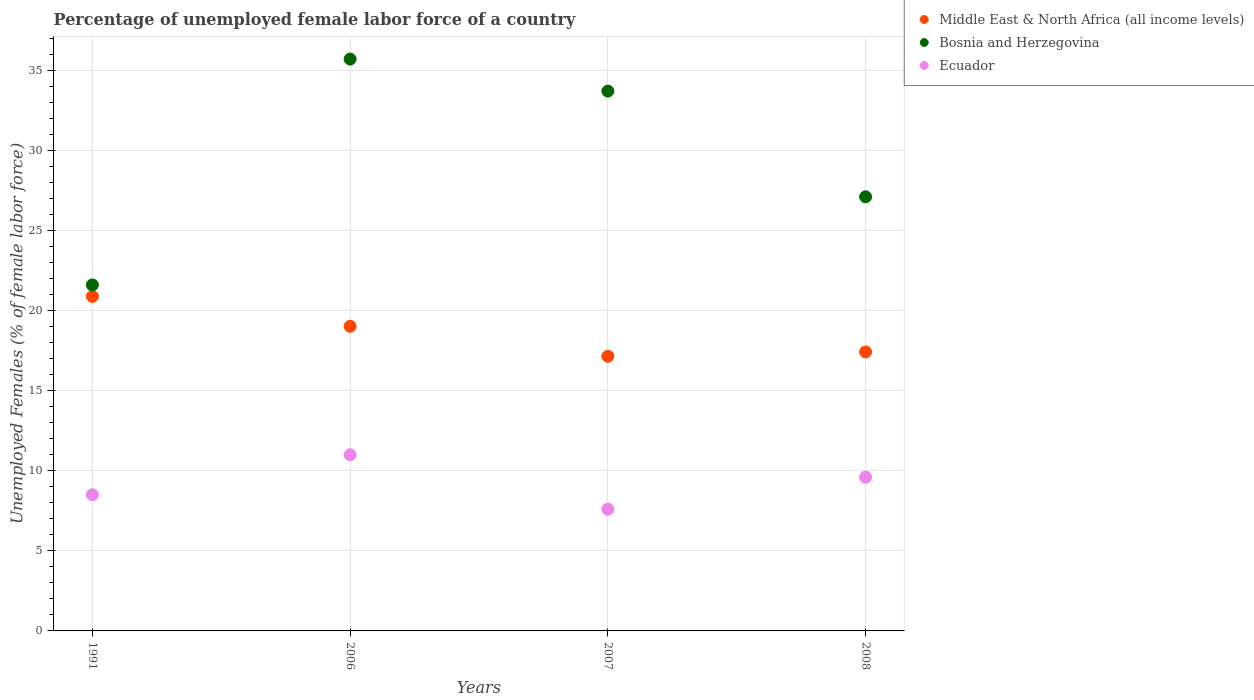What is the percentage of unemployed female labor force in Middle East & North Africa (all income levels) in 1991?
Make the answer very short. 20.88. Across all years, what is the minimum percentage of unemployed female labor force in Ecuador?
Give a very brief answer. 7.6. In which year was the percentage of unemployed female labor force in Ecuador maximum?
Provide a short and direct response. 2006. In which year was the percentage of unemployed female labor force in Middle East & North Africa (all income levels) minimum?
Offer a terse response. 2007. What is the total percentage of unemployed female labor force in Middle East & North Africa (all income levels) in the graph?
Give a very brief answer. 74.47. What is the difference between the percentage of unemployed female labor force in Bosnia and Herzegovina in 2006 and that in 2008?
Provide a short and direct response. 8.6. What is the difference between the percentage of unemployed female labor force in Bosnia and Herzegovina in 2006 and the percentage of unemployed female labor force in Middle East & North Africa (all income levels) in 1991?
Your answer should be very brief. 14.82. What is the average percentage of unemployed female labor force in Bosnia and Herzegovina per year?
Ensure brevity in your answer.  29.53. In the year 2007, what is the difference between the percentage of unemployed female labor force in Bosnia and Herzegovina and percentage of unemployed female labor force in Ecuador?
Offer a very short reply. 26.1. What is the ratio of the percentage of unemployed female labor force in Bosnia and Herzegovina in 1991 to that in 2007?
Make the answer very short. 0.64. What is the difference between the highest and the lowest percentage of unemployed female labor force in Middle East & North Africa (all income levels)?
Offer a terse response. 3.74. In how many years, is the percentage of unemployed female labor force in Middle East & North Africa (all income levels) greater than the average percentage of unemployed female labor force in Middle East & North Africa (all income levels) taken over all years?
Keep it short and to the point. 2. What is the difference between two consecutive major ticks on the Y-axis?
Your answer should be very brief. 5. Where does the legend appear in the graph?
Your response must be concise. Top right. What is the title of the graph?
Make the answer very short. Percentage of unemployed female labor force of a country. Does "United States" appear as one of the legend labels in the graph?
Give a very brief answer. No. What is the label or title of the X-axis?
Provide a succinct answer. Years. What is the label or title of the Y-axis?
Keep it short and to the point. Unemployed Females (% of female labor force). What is the Unemployed Females (% of female labor force) in Middle East & North Africa (all income levels) in 1991?
Offer a very short reply. 20.88. What is the Unemployed Females (% of female labor force) of Bosnia and Herzegovina in 1991?
Provide a succinct answer. 21.6. What is the Unemployed Females (% of female labor force) in Ecuador in 1991?
Ensure brevity in your answer.  8.5. What is the Unemployed Females (% of female labor force) in Middle East & North Africa (all income levels) in 2006?
Your answer should be very brief. 19.02. What is the Unemployed Females (% of female labor force) in Bosnia and Herzegovina in 2006?
Offer a terse response. 35.7. What is the Unemployed Females (% of female labor force) of Ecuador in 2006?
Offer a terse response. 11. What is the Unemployed Females (% of female labor force) in Middle East & North Africa (all income levels) in 2007?
Give a very brief answer. 17.15. What is the Unemployed Females (% of female labor force) in Bosnia and Herzegovina in 2007?
Ensure brevity in your answer.  33.7. What is the Unemployed Females (% of female labor force) of Ecuador in 2007?
Provide a succinct answer. 7.6. What is the Unemployed Females (% of female labor force) in Middle East & North Africa (all income levels) in 2008?
Offer a terse response. 17.41. What is the Unemployed Females (% of female labor force) in Bosnia and Herzegovina in 2008?
Provide a short and direct response. 27.1. What is the Unemployed Females (% of female labor force) in Ecuador in 2008?
Offer a terse response. 9.6. Across all years, what is the maximum Unemployed Females (% of female labor force) of Middle East & North Africa (all income levels)?
Give a very brief answer. 20.88. Across all years, what is the maximum Unemployed Females (% of female labor force) of Bosnia and Herzegovina?
Offer a terse response. 35.7. Across all years, what is the minimum Unemployed Females (% of female labor force) in Middle East & North Africa (all income levels)?
Your response must be concise. 17.15. Across all years, what is the minimum Unemployed Females (% of female labor force) of Bosnia and Herzegovina?
Your answer should be very brief. 21.6. Across all years, what is the minimum Unemployed Females (% of female labor force) in Ecuador?
Keep it short and to the point. 7.6. What is the total Unemployed Females (% of female labor force) of Middle East & North Africa (all income levels) in the graph?
Offer a terse response. 74.47. What is the total Unemployed Females (% of female labor force) of Bosnia and Herzegovina in the graph?
Provide a succinct answer. 118.1. What is the total Unemployed Females (% of female labor force) of Ecuador in the graph?
Offer a terse response. 36.7. What is the difference between the Unemployed Females (% of female labor force) in Middle East & North Africa (all income levels) in 1991 and that in 2006?
Make the answer very short. 1.87. What is the difference between the Unemployed Females (% of female labor force) of Bosnia and Herzegovina in 1991 and that in 2006?
Provide a short and direct response. -14.1. What is the difference between the Unemployed Females (% of female labor force) of Middle East & North Africa (all income levels) in 1991 and that in 2007?
Your answer should be compact. 3.74. What is the difference between the Unemployed Females (% of female labor force) in Bosnia and Herzegovina in 1991 and that in 2007?
Provide a succinct answer. -12.1. What is the difference between the Unemployed Females (% of female labor force) of Ecuador in 1991 and that in 2007?
Your answer should be compact. 0.9. What is the difference between the Unemployed Females (% of female labor force) of Middle East & North Africa (all income levels) in 1991 and that in 2008?
Your answer should be very brief. 3.47. What is the difference between the Unemployed Females (% of female labor force) in Bosnia and Herzegovina in 1991 and that in 2008?
Your answer should be compact. -5.5. What is the difference between the Unemployed Females (% of female labor force) in Ecuador in 1991 and that in 2008?
Offer a terse response. -1.1. What is the difference between the Unemployed Females (% of female labor force) of Middle East & North Africa (all income levels) in 2006 and that in 2007?
Ensure brevity in your answer.  1.87. What is the difference between the Unemployed Females (% of female labor force) in Middle East & North Africa (all income levels) in 2006 and that in 2008?
Keep it short and to the point. 1.6. What is the difference between the Unemployed Females (% of female labor force) of Ecuador in 2006 and that in 2008?
Make the answer very short. 1.4. What is the difference between the Unemployed Females (% of female labor force) in Middle East & North Africa (all income levels) in 2007 and that in 2008?
Offer a very short reply. -0.27. What is the difference between the Unemployed Females (% of female labor force) in Bosnia and Herzegovina in 2007 and that in 2008?
Your response must be concise. 6.6. What is the difference between the Unemployed Females (% of female labor force) in Middle East & North Africa (all income levels) in 1991 and the Unemployed Females (% of female labor force) in Bosnia and Herzegovina in 2006?
Your answer should be very brief. -14.82. What is the difference between the Unemployed Females (% of female labor force) of Middle East & North Africa (all income levels) in 1991 and the Unemployed Females (% of female labor force) of Ecuador in 2006?
Keep it short and to the point. 9.88. What is the difference between the Unemployed Females (% of female labor force) of Middle East & North Africa (all income levels) in 1991 and the Unemployed Females (% of female labor force) of Bosnia and Herzegovina in 2007?
Provide a short and direct response. -12.82. What is the difference between the Unemployed Females (% of female labor force) of Middle East & North Africa (all income levels) in 1991 and the Unemployed Females (% of female labor force) of Ecuador in 2007?
Offer a terse response. 13.28. What is the difference between the Unemployed Females (% of female labor force) of Middle East & North Africa (all income levels) in 1991 and the Unemployed Females (% of female labor force) of Bosnia and Herzegovina in 2008?
Offer a terse response. -6.22. What is the difference between the Unemployed Females (% of female labor force) of Middle East & North Africa (all income levels) in 1991 and the Unemployed Females (% of female labor force) of Ecuador in 2008?
Provide a succinct answer. 11.28. What is the difference between the Unemployed Females (% of female labor force) of Bosnia and Herzegovina in 1991 and the Unemployed Females (% of female labor force) of Ecuador in 2008?
Make the answer very short. 12. What is the difference between the Unemployed Females (% of female labor force) of Middle East & North Africa (all income levels) in 2006 and the Unemployed Females (% of female labor force) of Bosnia and Herzegovina in 2007?
Keep it short and to the point. -14.68. What is the difference between the Unemployed Females (% of female labor force) in Middle East & North Africa (all income levels) in 2006 and the Unemployed Females (% of female labor force) in Ecuador in 2007?
Keep it short and to the point. 11.42. What is the difference between the Unemployed Females (% of female labor force) of Bosnia and Herzegovina in 2006 and the Unemployed Females (% of female labor force) of Ecuador in 2007?
Ensure brevity in your answer.  28.1. What is the difference between the Unemployed Females (% of female labor force) of Middle East & North Africa (all income levels) in 2006 and the Unemployed Females (% of female labor force) of Bosnia and Herzegovina in 2008?
Keep it short and to the point. -8.08. What is the difference between the Unemployed Females (% of female labor force) in Middle East & North Africa (all income levels) in 2006 and the Unemployed Females (% of female labor force) in Ecuador in 2008?
Your answer should be very brief. 9.42. What is the difference between the Unemployed Females (% of female labor force) in Bosnia and Herzegovina in 2006 and the Unemployed Females (% of female labor force) in Ecuador in 2008?
Make the answer very short. 26.1. What is the difference between the Unemployed Females (% of female labor force) of Middle East & North Africa (all income levels) in 2007 and the Unemployed Females (% of female labor force) of Bosnia and Herzegovina in 2008?
Make the answer very short. -9.95. What is the difference between the Unemployed Females (% of female labor force) of Middle East & North Africa (all income levels) in 2007 and the Unemployed Females (% of female labor force) of Ecuador in 2008?
Provide a succinct answer. 7.55. What is the difference between the Unemployed Females (% of female labor force) of Bosnia and Herzegovina in 2007 and the Unemployed Females (% of female labor force) of Ecuador in 2008?
Offer a terse response. 24.1. What is the average Unemployed Females (% of female labor force) of Middle East & North Africa (all income levels) per year?
Your response must be concise. 18.62. What is the average Unemployed Females (% of female labor force) of Bosnia and Herzegovina per year?
Your answer should be compact. 29.52. What is the average Unemployed Females (% of female labor force) of Ecuador per year?
Keep it short and to the point. 9.18. In the year 1991, what is the difference between the Unemployed Females (% of female labor force) in Middle East & North Africa (all income levels) and Unemployed Females (% of female labor force) in Bosnia and Herzegovina?
Provide a succinct answer. -0.72. In the year 1991, what is the difference between the Unemployed Females (% of female labor force) of Middle East & North Africa (all income levels) and Unemployed Females (% of female labor force) of Ecuador?
Make the answer very short. 12.38. In the year 2006, what is the difference between the Unemployed Females (% of female labor force) in Middle East & North Africa (all income levels) and Unemployed Females (% of female labor force) in Bosnia and Herzegovina?
Make the answer very short. -16.68. In the year 2006, what is the difference between the Unemployed Females (% of female labor force) of Middle East & North Africa (all income levels) and Unemployed Females (% of female labor force) of Ecuador?
Provide a succinct answer. 8.02. In the year 2006, what is the difference between the Unemployed Females (% of female labor force) in Bosnia and Herzegovina and Unemployed Females (% of female labor force) in Ecuador?
Your response must be concise. 24.7. In the year 2007, what is the difference between the Unemployed Females (% of female labor force) of Middle East & North Africa (all income levels) and Unemployed Females (% of female labor force) of Bosnia and Herzegovina?
Your answer should be compact. -16.55. In the year 2007, what is the difference between the Unemployed Females (% of female labor force) in Middle East & North Africa (all income levels) and Unemployed Females (% of female labor force) in Ecuador?
Provide a short and direct response. 9.55. In the year 2007, what is the difference between the Unemployed Females (% of female labor force) in Bosnia and Herzegovina and Unemployed Females (% of female labor force) in Ecuador?
Give a very brief answer. 26.1. In the year 2008, what is the difference between the Unemployed Females (% of female labor force) in Middle East & North Africa (all income levels) and Unemployed Females (% of female labor force) in Bosnia and Herzegovina?
Provide a short and direct response. -9.69. In the year 2008, what is the difference between the Unemployed Females (% of female labor force) in Middle East & North Africa (all income levels) and Unemployed Females (% of female labor force) in Ecuador?
Your answer should be very brief. 7.81. What is the ratio of the Unemployed Females (% of female labor force) of Middle East & North Africa (all income levels) in 1991 to that in 2006?
Make the answer very short. 1.1. What is the ratio of the Unemployed Females (% of female labor force) of Bosnia and Herzegovina in 1991 to that in 2006?
Ensure brevity in your answer.  0.6. What is the ratio of the Unemployed Females (% of female labor force) of Ecuador in 1991 to that in 2006?
Your answer should be very brief. 0.77. What is the ratio of the Unemployed Females (% of female labor force) in Middle East & North Africa (all income levels) in 1991 to that in 2007?
Make the answer very short. 1.22. What is the ratio of the Unemployed Females (% of female labor force) of Bosnia and Herzegovina in 1991 to that in 2007?
Provide a succinct answer. 0.64. What is the ratio of the Unemployed Females (% of female labor force) of Ecuador in 1991 to that in 2007?
Your response must be concise. 1.12. What is the ratio of the Unemployed Females (% of female labor force) of Middle East & North Africa (all income levels) in 1991 to that in 2008?
Provide a succinct answer. 1.2. What is the ratio of the Unemployed Females (% of female labor force) of Bosnia and Herzegovina in 1991 to that in 2008?
Make the answer very short. 0.8. What is the ratio of the Unemployed Females (% of female labor force) of Ecuador in 1991 to that in 2008?
Offer a terse response. 0.89. What is the ratio of the Unemployed Females (% of female labor force) of Middle East & North Africa (all income levels) in 2006 to that in 2007?
Your answer should be compact. 1.11. What is the ratio of the Unemployed Females (% of female labor force) of Bosnia and Herzegovina in 2006 to that in 2007?
Keep it short and to the point. 1.06. What is the ratio of the Unemployed Females (% of female labor force) of Ecuador in 2006 to that in 2007?
Provide a short and direct response. 1.45. What is the ratio of the Unemployed Females (% of female labor force) of Middle East & North Africa (all income levels) in 2006 to that in 2008?
Your response must be concise. 1.09. What is the ratio of the Unemployed Females (% of female labor force) of Bosnia and Herzegovina in 2006 to that in 2008?
Offer a terse response. 1.32. What is the ratio of the Unemployed Females (% of female labor force) in Ecuador in 2006 to that in 2008?
Offer a terse response. 1.15. What is the ratio of the Unemployed Females (% of female labor force) of Middle East & North Africa (all income levels) in 2007 to that in 2008?
Give a very brief answer. 0.98. What is the ratio of the Unemployed Females (% of female labor force) of Bosnia and Herzegovina in 2007 to that in 2008?
Ensure brevity in your answer.  1.24. What is the ratio of the Unemployed Females (% of female labor force) in Ecuador in 2007 to that in 2008?
Ensure brevity in your answer.  0.79. What is the difference between the highest and the second highest Unemployed Females (% of female labor force) of Middle East & North Africa (all income levels)?
Provide a short and direct response. 1.87. What is the difference between the highest and the lowest Unemployed Females (% of female labor force) of Middle East & North Africa (all income levels)?
Make the answer very short. 3.74. What is the difference between the highest and the lowest Unemployed Females (% of female labor force) of Bosnia and Herzegovina?
Your response must be concise. 14.1. What is the difference between the highest and the lowest Unemployed Females (% of female labor force) of Ecuador?
Keep it short and to the point. 3.4. 